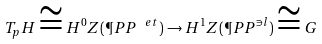<formula> <loc_0><loc_0><loc_500><loc_500>T _ { p } H \cong H ^ { 0 } Z ( \P P P ^ { \ e t } ) \to H ^ { 1 } Z ( \P P P ^ { \ni l } ) \cong G</formula> 